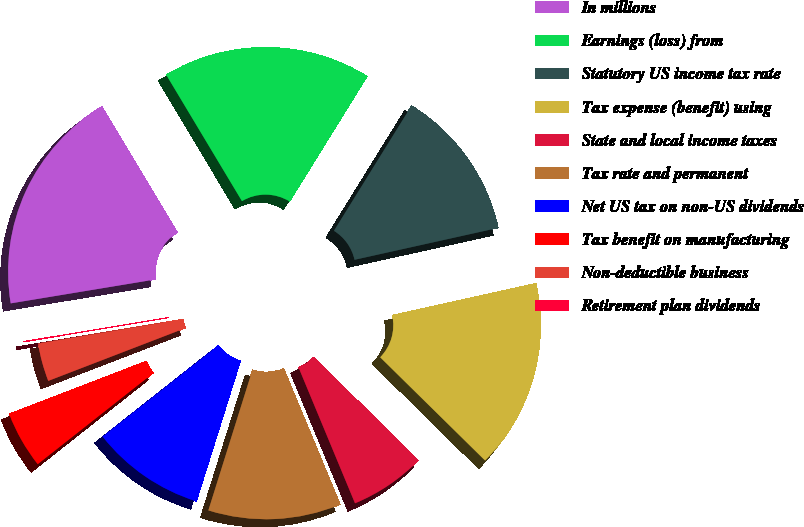Convert chart. <chart><loc_0><loc_0><loc_500><loc_500><pie_chart><fcel>In millions<fcel>Earnings (loss) from<fcel>Statutory US income tax rate<fcel>Tax expense (benefit) using<fcel>State and local income taxes<fcel>Tax rate and permanent<fcel>Net US tax on non-US dividends<fcel>Tax benefit on manufacturing<fcel>Non-deductible business<fcel>Retirement plan dividends<nl><fcel>19.01%<fcel>17.43%<fcel>12.69%<fcel>15.85%<fcel>6.36%<fcel>11.11%<fcel>9.53%<fcel>4.78%<fcel>3.2%<fcel>0.04%<nl></chart> 